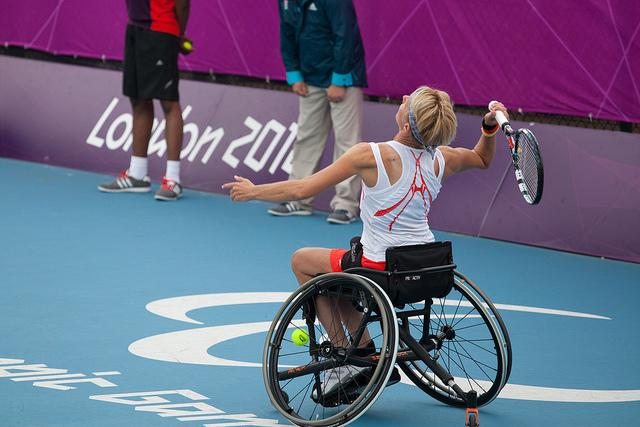In which class of the sport does the tennis player compete? Please explain your reasoning. wheelchair. The player is in a chair while competing. 